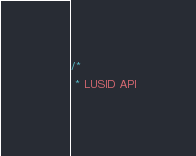Convert code to text. <code><loc_0><loc_0><loc_500><loc_500><_Java_>/*
 * LUSID API</code> 